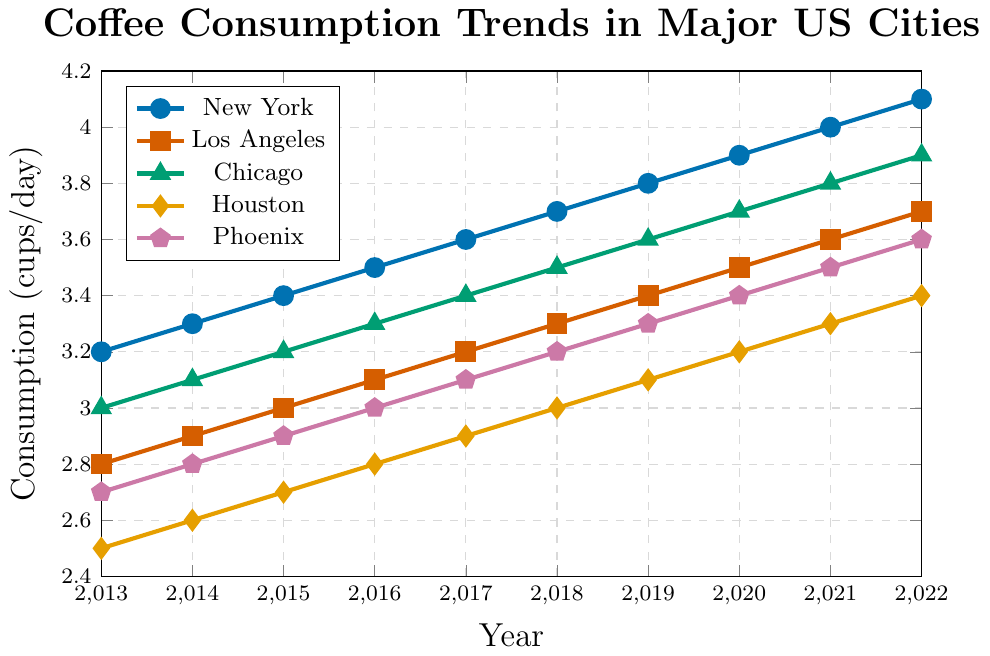What's the trend in coffee consumption for New York over the past decade? From the figure, the line representing New York consistently increases from 3.2 to 4.1 cups/day over the years 2013 to 2022. This indicates an upward trend in coffee consumption in New York.
Answer: Upward trend Which city had the lowest coffee consumption in 2013? In 2013, the line representing Houston is the lowest, starting at 2.5 cups/day.
Answer: Houston By how much did coffee consumption increase in Phoenix from 2013 to 2022? The coffee consumption in Phoenix increased from 2.7 cups/day in 2013 to 3.6 cups/day in 2022. The increase is 3.6 - 2.7 = 0.9 cups/day.
Answer: 0.9 cups/day Which two cities had the highest and lowest coffee consumption in 2022? In 2022, New York had the highest coffee consumption at 4.1 cups/day and Houston had the lowest at 3.4 cups/day.
Answer: New York and Houston How does the coffee consumption in Chicago in 2015 compare to that in Los Angeles in 2017? In 2015, Chicago's coffee consumption was 3.2 cups/day, while in 2017, Los Angeles's coffee consumption was 3.2 cups/day. Therefore, both cities had the same coffee consumption in the respective years.
Answer: Same Which city showed the most significant increase in coffee consumption from 2013 to 2022? To determine the city with the most significant increase, compare the differences over the years:
New York: 4.1 - 3.2 = 0.9
Los Angeles: 3.7 - 2.8 = 0.9
Chicago: 3.9 - 3.0 = 0.9
Houston: 3.4 - 2.5 = 0.9
Phoenix: 3.6 - 2.7 = 0.9
All cities had the same increase of 0.9 cups/day.
Answer: All cities What is the difference in coffee consumption between Los Angeles and Houston in 2020? In 2020, the coffee consumption was 3.5 cups/day in Los Angeles and 3.2 cups/day in Houston. The difference is 3.5 - 3.2 = 0.3 cups/day.
Answer: 0.3 cups/day Is there any year where all cities had a uniform increase in coffee consumption? From the data, every year shows a uniform increase (0.1 cups/day) for all cities between any two consecutive years.
Answer: Yes What is the average coffee consumption in 2017 for all five cities? First, sum the coffee consumption values for 2017: 3.6 (New York) + 3.2 (Los Angeles) + 3.4 (Chicago) + 2.9 (Houston) + 3.1 (Phoenix) = 16.2. The average is 16.2 / 5 = 3.24 cups/day.
Answer: 3.24 cups/day How did the coffee consumption in Houston change from 2013 to 2018? In 2013, Houston's consumption was 2.5 cups/day, and in 2018 it was 3.0 cups/day. The change is 3.0 - 2.5 = 0.5 cups/day increase.
Answer: 0.5 cups/day increase 